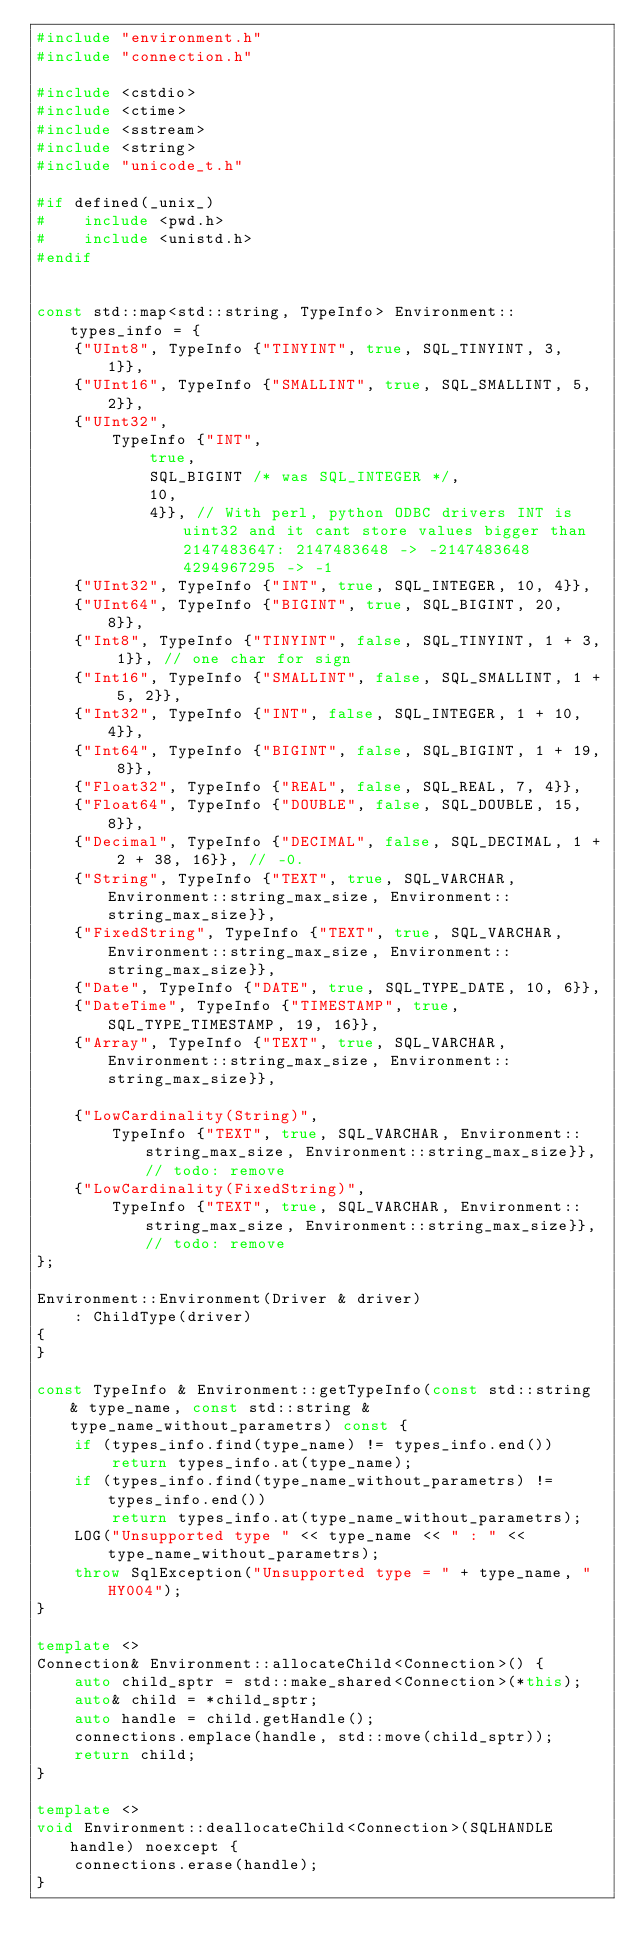<code> <loc_0><loc_0><loc_500><loc_500><_C++_>#include "environment.h"
#include "connection.h"

#include <cstdio>
#include <ctime>
#include <sstream>
#include <string>
#include "unicode_t.h"

#if defined(_unix_)
#    include <pwd.h>
#    include <unistd.h>
#endif


const std::map<std::string, TypeInfo> Environment::types_info = {
    {"UInt8", TypeInfo {"TINYINT", true, SQL_TINYINT, 3, 1}},
    {"UInt16", TypeInfo {"SMALLINT", true, SQL_SMALLINT, 5, 2}},
    {"UInt32",
        TypeInfo {"INT",
            true,
            SQL_BIGINT /* was SQL_INTEGER */,
            10,
            4}}, // With perl, python ODBC drivers INT is uint32 and it cant store values bigger than 2147483647: 2147483648 -> -2147483648 4294967295 -> -1
    {"UInt32", TypeInfo {"INT", true, SQL_INTEGER, 10, 4}},
    {"UInt64", TypeInfo {"BIGINT", true, SQL_BIGINT, 20, 8}},
    {"Int8", TypeInfo {"TINYINT", false, SQL_TINYINT, 1 + 3, 1}}, // one char for sign
    {"Int16", TypeInfo {"SMALLINT", false, SQL_SMALLINT, 1 + 5, 2}},
    {"Int32", TypeInfo {"INT", false, SQL_INTEGER, 1 + 10, 4}},
    {"Int64", TypeInfo {"BIGINT", false, SQL_BIGINT, 1 + 19, 8}},
    {"Float32", TypeInfo {"REAL", false, SQL_REAL, 7, 4}},
    {"Float64", TypeInfo {"DOUBLE", false, SQL_DOUBLE, 15, 8}},
    {"Decimal", TypeInfo {"DECIMAL", false, SQL_DECIMAL, 1 + 2 + 38, 16}}, // -0.
    {"String", TypeInfo {"TEXT", true, SQL_VARCHAR, Environment::string_max_size, Environment::string_max_size}},
    {"FixedString", TypeInfo {"TEXT", true, SQL_VARCHAR, Environment::string_max_size, Environment::string_max_size}},
    {"Date", TypeInfo {"DATE", true, SQL_TYPE_DATE, 10, 6}},
    {"DateTime", TypeInfo {"TIMESTAMP", true, SQL_TYPE_TIMESTAMP, 19, 16}},
    {"Array", TypeInfo {"TEXT", true, SQL_VARCHAR, Environment::string_max_size, Environment::string_max_size}},

    {"LowCardinality(String)",
        TypeInfo {"TEXT", true, SQL_VARCHAR, Environment::string_max_size, Environment::string_max_size}}, // todo: remove
    {"LowCardinality(FixedString)",
        TypeInfo {"TEXT", true, SQL_VARCHAR, Environment::string_max_size, Environment::string_max_size}}, // todo: remove
};

Environment::Environment(Driver & driver)
    : ChildType(driver)
{
}

const TypeInfo & Environment::getTypeInfo(const std::string & type_name, const std::string & type_name_without_parametrs) const {
    if (types_info.find(type_name) != types_info.end())
        return types_info.at(type_name);
    if (types_info.find(type_name_without_parametrs) != types_info.end())
        return types_info.at(type_name_without_parametrs);
    LOG("Unsupported type " << type_name << " : " << type_name_without_parametrs);
    throw SqlException("Unsupported type = " + type_name, "HY004");
}

template <>
Connection& Environment::allocateChild<Connection>() {
    auto child_sptr = std::make_shared<Connection>(*this);
    auto& child = *child_sptr;
    auto handle = child.getHandle();
    connections.emplace(handle, std::move(child_sptr));
    return child;
}

template <>
void Environment::deallocateChild<Connection>(SQLHANDLE handle) noexcept {
    connections.erase(handle);
}
</code> 